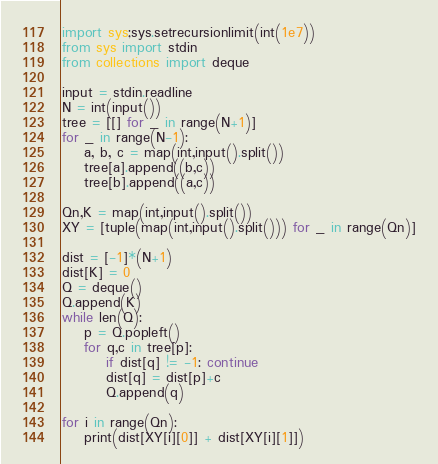<code> <loc_0><loc_0><loc_500><loc_500><_Python_>import sys;sys.setrecursionlimit(int(1e7))
from sys import stdin
from collections import deque

input = stdin.readline
N = int(input())
tree = [[] for _ in range(N+1)]
for _ in range(N-1):
    a, b, c = map(int,input().split())
    tree[a].append((b,c))
    tree[b].append((a,c))

Qn,K = map(int,input().split())
XY = [tuple(map(int,input().split())) for _ in range(Qn)]

dist = [-1]*(N+1)
dist[K] = 0
Q = deque()
Q.append(K)
while len(Q):
    p = Q.popleft()
    for q,c in tree[p]:
        if dist[q] != -1: continue
        dist[q] = dist[p]+c
        Q.append(q)

for i in range(Qn):
    print(dist[XY[i][0]] + dist[XY[i][1]])</code> 